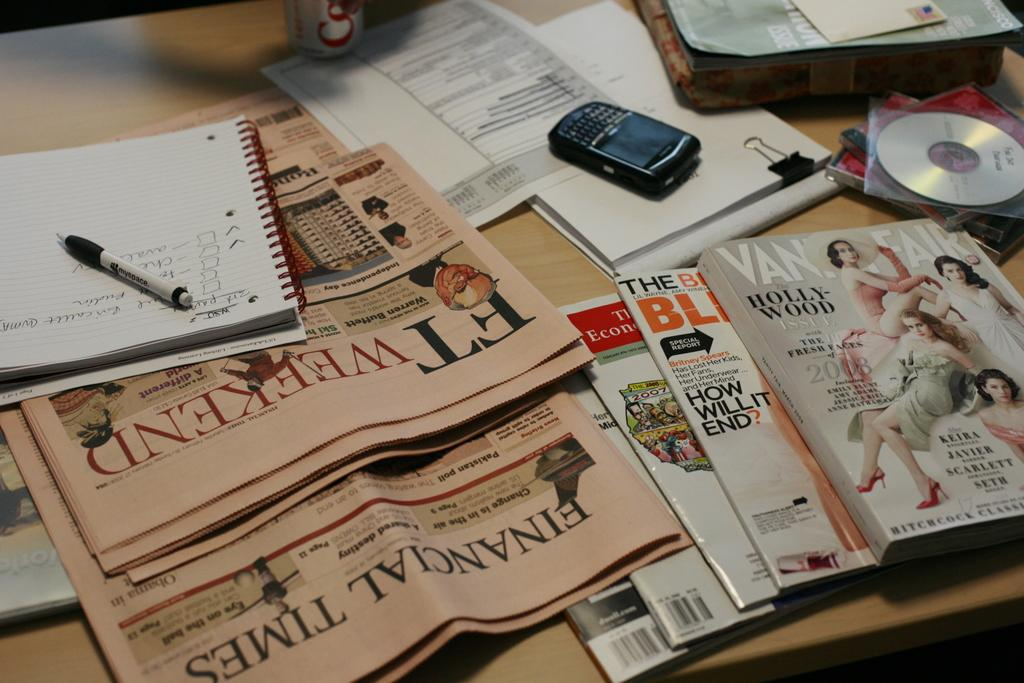<image>
Present a compact description of the photo's key features. Newspapers and a stack of magazines with Vanity Fair at the top 